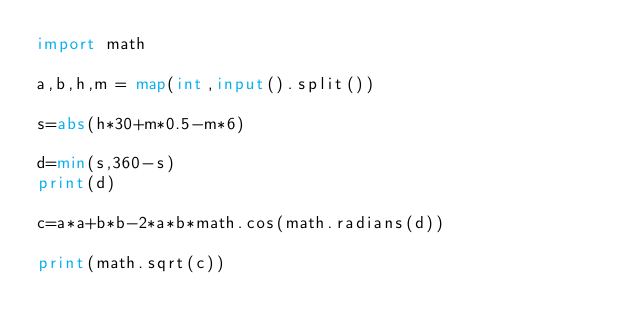Convert code to text. <code><loc_0><loc_0><loc_500><loc_500><_Python_>import math

a,b,h,m = map(int,input().split())

s=abs(h*30+m*0.5-m*6)

d=min(s,360-s)
print(d)

c=a*a+b*b-2*a*b*math.cos(math.radians(d))

print(math.sqrt(c))</code> 